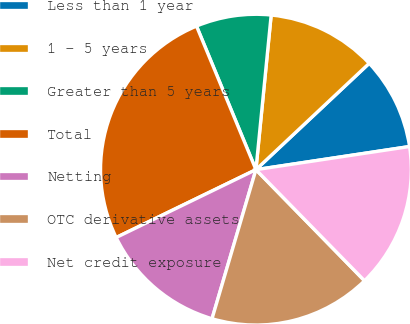<chart> <loc_0><loc_0><loc_500><loc_500><pie_chart><fcel>Less than 1 year<fcel>1 - 5 years<fcel>Greater than 5 years<fcel>Total<fcel>Netting<fcel>OTC derivative assets<fcel>Net credit exposure<nl><fcel>9.62%<fcel>11.44%<fcel>7.81%<fcel>25.95%<fcel>13.25%<fcel>16.88%<fcel>15.06%<nl></chart> 